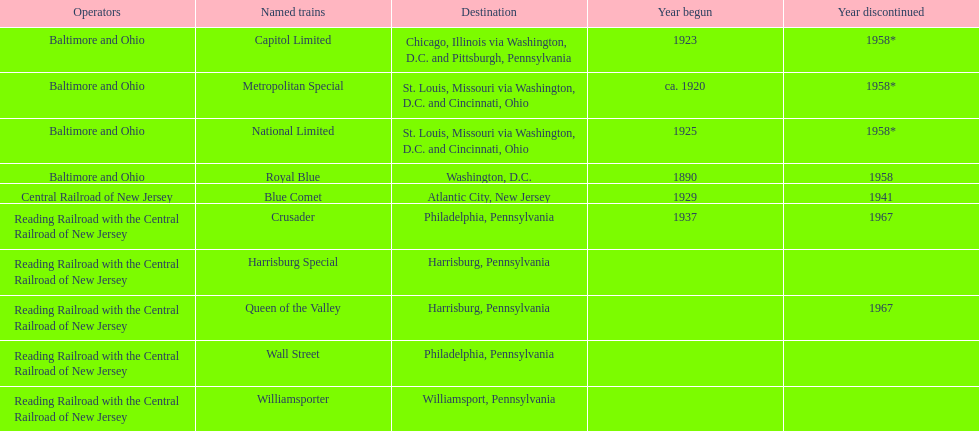What was the first train to begin service? Royal Blue. 